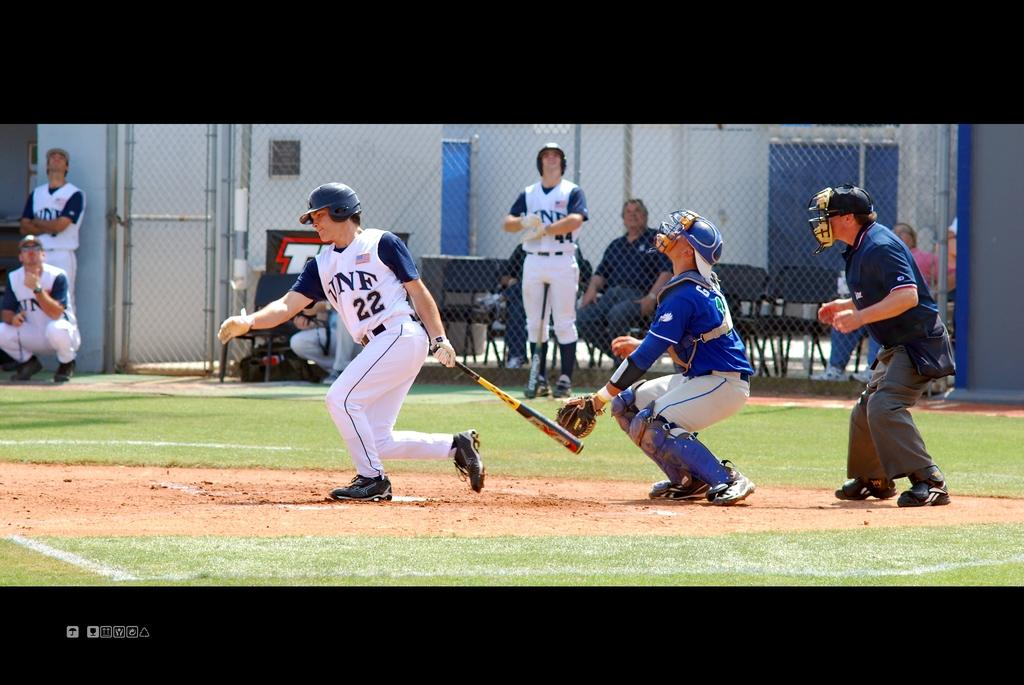<image>
Describe the image concisely. Player number 22 is dropping his bat in preparation to run the bases. 